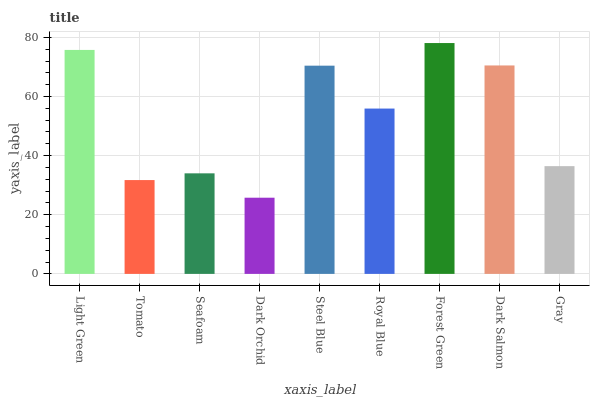Is Dark Orchid the minimum?
Answer yes or no. Yes. Is Forest Green the maximum?
Answer yes or no. Yes. Is Tomato the minimum?
Answer yes or no. No. Is Tomato the maximum?
Answer yes or no. No. Is Light Green greater than Tomato?
Answer yes or no. Yes. Is Tomato less than Light Green?
Answer yes or no. Yes. Is Tomato greater than Light Green?
Answer yes or no. No. Is Light Green less than Tomato?
Answer yes or no. No. Is Royal Blue the high median?
Answer yes or no. Yes. Is Royal Blue the low median?
Answer yes or no. Yes. Is Dark Orchid the high median?
Answer yes or no. No. Is Tomato the low median?
Answer yes or no. No. 